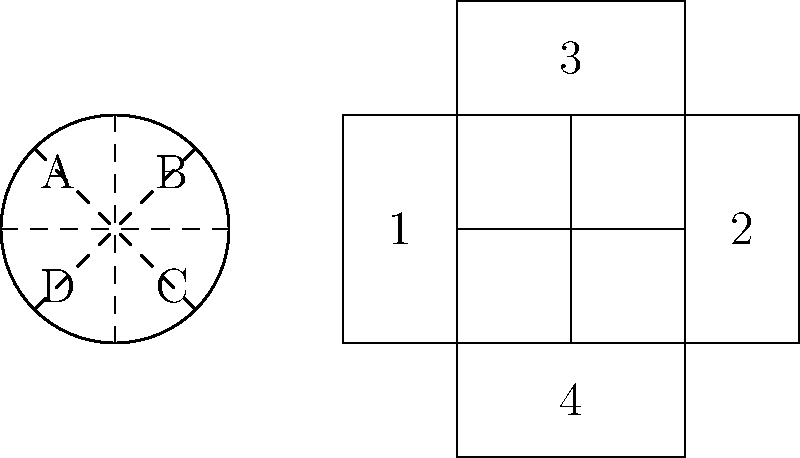A traditional Asian paper lantern is shown on the left, with dashed lines indicating fold lines. Which of the numbered sections in the unfolded pattern on the right corresponds to the area labeled 'A' in the folded lantern? To solve this problem, we need to follow these steps:

1. Observe the folded lantern on the left:
   - It's circular with four sections (A, B, C, D) divided by dashed fold lines.
   - Section A is in the top-left quadrant.

2. Analyze the unfolded pattern on the right:
   - It consists of four rectangular sections numbered 1 to 4.
   - Sections 1 and 2 are side by side, while 3 is above and 4 is below.

3. Consider the folding process:
   - The circular shape suggests that opposite sections will fold towards each other.
   - Sections 1 and 2 will form the sides of the lantern.
   - Sections 3 and 4 will form the top and bottom.

4. Identify section A's position:
   - A is in the top-left quadrant of the folded lantern.
   - This means it should be in the left half of the top section when unfolded.

5. Match A to the unfolded pattern:
   - Section 3 is the top section of the unfolded pattern.
   - The left half of section 3 corresponds to area A in the folded lantern.

Therefore, section 3 in the unfolded pattern corresponds to area A in the folded lantern.
Answer: 3 